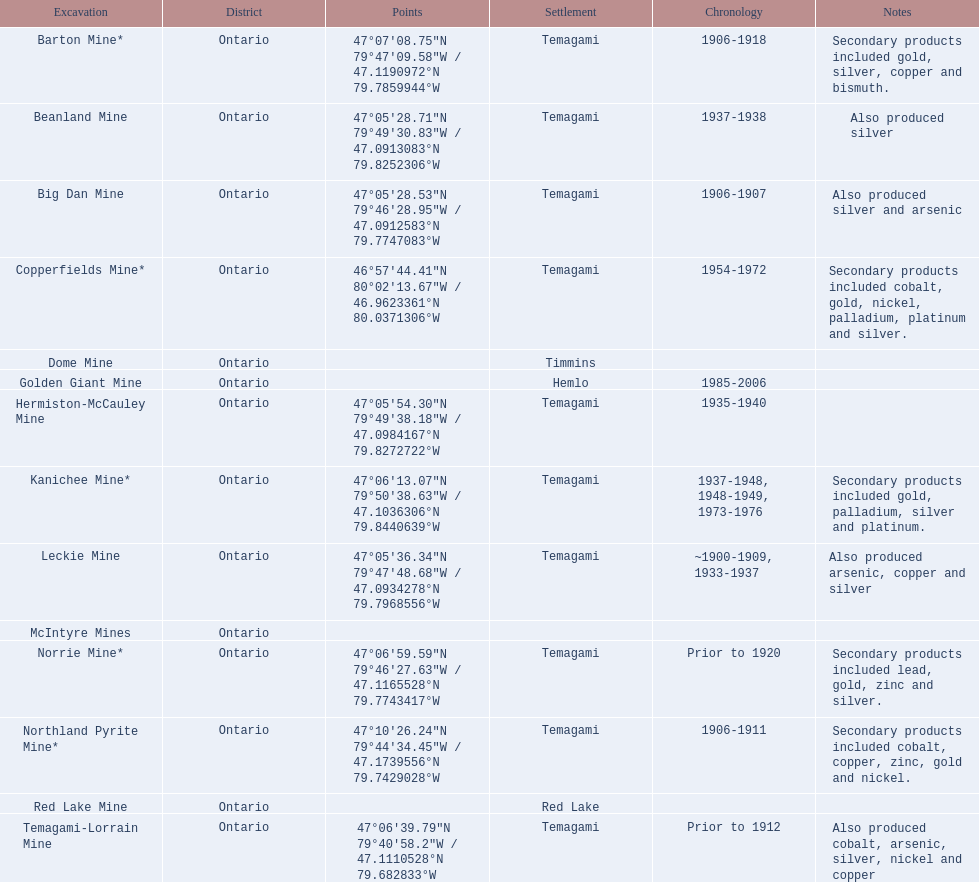What dates was the golden giant mine open? 1985-2006. What dates was the beanland mine open? 1937-1938. Of those mines, which was open longer? Golden Giant Mine. 